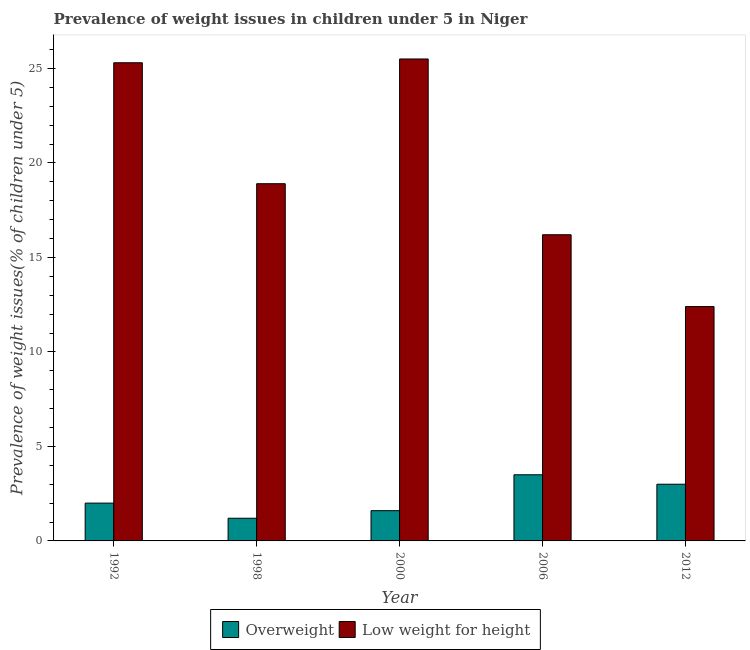How many groups of bars are there?
Your response must be concise. 5. Are the number of bars per tick equal to the number of legend labels?
Your answer should be very brief. Yes. Are the number of bars on each tick of the X-axis equal?
Ensure brevity in your answer.  Yes. How many bars are there on the 5th tick from the left?
Give a very brief answer. 2. How many bars are there on the 2nd tick from the right?
Your response must be concise. 2. What is the label of the 4th group of bars from the left?
Your answer should be very brief. 2006. What is the percentage of overweight children in 2000?
Your answer should be very brief. 1.6. Across all years, what is the maximum percentage of underweight children?
Give a very brief answer. 25.5. Across all years, what is the minimum percentage of overweight children?
Provide a short and direct response. 1.2. In which year was the percentage of overweight children maximum?
Offer a very short reply. 2006. In which year was the percentage of overweight children minimum?
Your response must be concise. 1998. What is the total percentage of underweight children in the graph?
Provide a succinct answer. 98.3. What is the difference between the percentage of overweight children in 1992 and that in 2012?
Provide a short and direct response. -1. What is the difference between the percentage of underweight children in 2012 and the percentage of overweight children in 2006?
Offer a very short reply. -3.8. What is the average percentage of overweight children per year?
Provide a short and direct response. 2.26. What is the ratio of the percentage of underweight children in 1992 to that in 2012?
Your answer should be very brief. 2.04. What is the difference between the highest and the second highest percentage of underweight children?
Give a very brief answer. 0.2. What is the difference between the highest and the lowest percentage of overweight children?
Keep it short and to the point. 2.3. What does the 1st bar from the left in 2006 represents?
Give a very brief answer. Overweight. What does the 1st bar from the right in 1998 represents?
Keep it short and to the point. Low weight for height. How many years are there in the graph?
Keep it short and to the point. 5. Are the values on the major ticks of Y-axis written in scientific E-notation?
Provide a succinct answer. No. Does the graph contain grids?
Make the answer very short. No. What is the title of the graph?
Provide a succinct answer. Prevalence of weight issues in children under 5 in Niger. What is the label or title of the X-axis?
Your response must be concise. Year. What is the label or title of the Y-axis?
Your answer should be compact. Prevalence of weight issues(% of children under 5). What is the Prevalence of weight issues(% of children under 5) of Low weight for height in 1992?
Give a very brief answer. 25.3. What is the Prevalence of weight issues(% of children under 5) of Overweight in 1998?
Keep it short and to the point. 1.2. What is the Prevalence of weight issues(% of children under 5) of Low weight for height in 1998?
Offer a very short reply. 18.9. What is the Prevalence of weight issues(% of children under 5) of Overweight in 2000?
Ensure brevity in your answer.  1.6. What is the Prevalence of weight issues(% of children under 5) of Low weight for height in 2006?
Provide a succinct answer. 16.2. What is the Prevalence of weight issues(% of children under 5) of Low weight for height in 2012?
Provide a succinct answer. 12.4. Across all years, what is the maximum Prevalence of weight issues(% of children under 5) of Overweight?
Make the answer very short. 3.5. Across all years, what is the minimum Prevalence of weight issues(% of children under 5) of Overweight?
Ensure brevity in your answer.  1.2. Across all years, what is the minimum Prevalence of weight issues(% of children under 5) of Low weight for height?
Make the answer very short. 12.4. What is the total Prevalence of weight issues(% of children under 5) in Overweight in the graph?
Your answer should be very brief. 11.3. What is the total Prevalence of weight issues(% of children under 5) in Low weight for height in the graph?
Provide a succinct answer. 98.3. What is the difference between the Prevalence of weight issues(% of children under 5) in Low weight for height in 1992 and that in 1998?
Make the answer very short. 6.4. What is the difference between the Prevalence of weight issues(% of children under 5) in Low weight for height in 1992 and that in 2000?
Your answer should be very brief. -0.2. What is the difference between the Prevalence of weight issues(% of children under 5) in Overweight in 1992 and that in 2012?
Offer a terse response. -1. What is the difference between the Prevalence of weight issues(% of children under 5) of Low weight for height in 1998 and that in 2000?
Keep it short and to the point. -6.6. What is the difference between the Prevalence of weight issues(% of children under 5) of Overweight in 1998 and that in 2006?
Give a very brief answer. -2.3. What is the difference between the Prevalence of weight issues(% of children under 5) in Low weight for height in 1998 and that in 2006?
Provide a succinct answer. 2.7. What is the difference between the Prevalence of weight issues(% of children under 5) of Overweight in 1998 and that in 2012?
Make the answer very short. -1.8. What is the difference between the Prevalence of weight issues(% of children under 5) in Overweight in 2000 and that in 2006?
Give a very brief answer. -1.9. What is the difference between the Prevalence of weight issues(% of children under 5) in Overweight in 2000 and that in 2012?
Provide a succinct answer. -1.4. What is the difference between the Prevalence of weight issues(% of children under 5) of Low weight for height in 2000 and that in 2012?
Provide a short and direct response. 13.1. What is the difference between the Prevalence of weight issues(% of children under 5) of Low weight for height in 2006 and that in 2012?
Provide a short and direct response. 3.8. What is the difference between the Prevalence of weight issues(% of children under 5) in Overweight in 1992 and the Prevalence of weight issues(% of children under 5) in Low weight for height in 1998?
Your answer should be very brief. -16.9. What is the difference between the Prevalence of weight issues(% of children under 5) in Overweight in 1992 and the Prevalence of weight issues(% of children under 5) in Low weight for height in 2000?
Your response must be concise. -23.5. What is the difference between the Prevalence of weight issues(% of children under 5) of Overweight in 1992 and the Prevalence of weight issues(% of children under 5) of Low weight for height in 2012?
Provide a short and direct response. -10.4. What is the difference between the Prevalence of weight issues(% of children under 5) of Overweight in 1998 and the Prevalence of weight issues(% of children under 5) of Low weight for height in 2000?
Your answer should be compact. -24.3. What is the difference between the Prevalence of weight issues(% of children under 5) in Overweight in 1998 and the Prevalence of weight issues(% of children under 5) in Low weight for height in 2006?
Offer a very short reply. -15. What is the difference between the Prevalence of weight issues(% of children under 5) of Overweight in 2000 and the Prevalence of weight issues(% of children under 5) of Low weight for height in 2006?
Provide a succinct answer. -14.6. What is the difference between the Prevalence of weight issues(% of children under 5) in Overweight in 2000 and the Prevalence of weight issues(% of children under 5) in Low weight for height in 2012?
Make the answer very short. -10.8. What is the average Prevalence of weight issues(% of children under 5) in Overweight per year?
Ensure brevity in your answer.  2.26. What is the average Prevalence of weight issues(% of children under 5) in Low weight for height per year?
Provide a succinct answer. 19.66. In the year 1992, what is the difference between the Prevalence of weight issues(% of children under 5) of Overweight and Prevalence of weight issues(% of children under 5) of Low weight for height?
Keep it short and to the point. -23.3. In the year 1998, what is the difference between the Prevalence of weight issues(% of children under 5) in Overweight and Prevalence of weight issues(% of children under 5) in Low weight for height?
Your answer should be very brief. -17.7. In the year 2000, what is the difference between the Prevalence of weight issues(% of children under 5) of Overweight and Prevalence of weight issues(% of children under 5) of Low weight for height?
Offer a terse response. -23.9. What is the ratio of the Prevalence of weight issues(% of children under 5) of Overweight in 1992 to that in 1998?
Your answer should be compact. 1.67. What is the ratio of the Prevalence of weight issues(% of children under 5) of Low weight for height in 1992 to that in 1998?
Your response must be concise. 1.34. What is the ratio of the Prevalence of weight issues(% of children under 5) of Overweight in 1992 to that in 2006?
Make the answer very short. 0.57. What is the ratio of the Prevalence of weight issues(% of children under 5) in Low weight for height in 1992 to that in 2006?
Keep it short and to the point. 1.56. What is the ratio of the Prevalence of weight issues(% of children under 5) in Overweight in 1992 to that in 2012?
Your answer should be compact. 0.67. What is the ratio of the Prevalence of weight issues(% of children under 5) of Low weight for height in 1992 to that in 2012?
Make the answer very short. 2.04. What is the ratio of the Prevalence of weight issues(% of children under 5) in Low weight for height in 1998 to that in 2000?
Offer a terse response. 0.74. What is the ratio of the Prevalence of weight issues(% of children under 5) of Overweight in 1998 to that in 2006?
Provide a short and direct response. 0.34. What is the ratio of the Prevalence of weight issues(% of children under 5) of Overweight in 1998 to that in 2012?
Ensure brevity in your answer.  0.4. What is the ratio of the Prevalence of weight issues(% of children under 5) of Low weight for height in 1998 to that in 2012?
Your answer should be very brief. 1.52. What is the ratio of the Prevalence of weight issues(% of children under 5) in Overweight in 2000 to that in 2006?
Offer a very short reply. 0.46. What is the ratio of the Prevalence of weight issues(% of children under 5) in Low weight for height in 2000 to that in 2006?
Keep it short and to the point. 1.57. What is the ratio of the Prevalence of weight issues(% of children under 5) in Overweight in 2000 to that in 2012?
Offer a terse response. 0.53. What is the ratio of the Prevalence of weight issues(% of children under 5) of Low weight for height in 2000 to that in 2012?
Provide a succinct answer. 2.06. What is the ratio of the Prevalence of weight issues(% of children under 5) in Overweight in 2006 to that in 2012?
Make the answer very short. 1.17. What is the ratio of the Prevalence of weight issues(% of children under 5) of Low weight for height in 2006 to that in 2012?
Give a very brief answer. 1.31. What is the difference between the highest and the second highest Prevalence of weight issues(% of children under 5) in Low weight for height?
Ensure brevity in your answer.  0.2. What is the difference between the highest and the lowest Prevalence of weight issues(% of children under 5) of Overweight?
Make the answer very short. 2.3. 